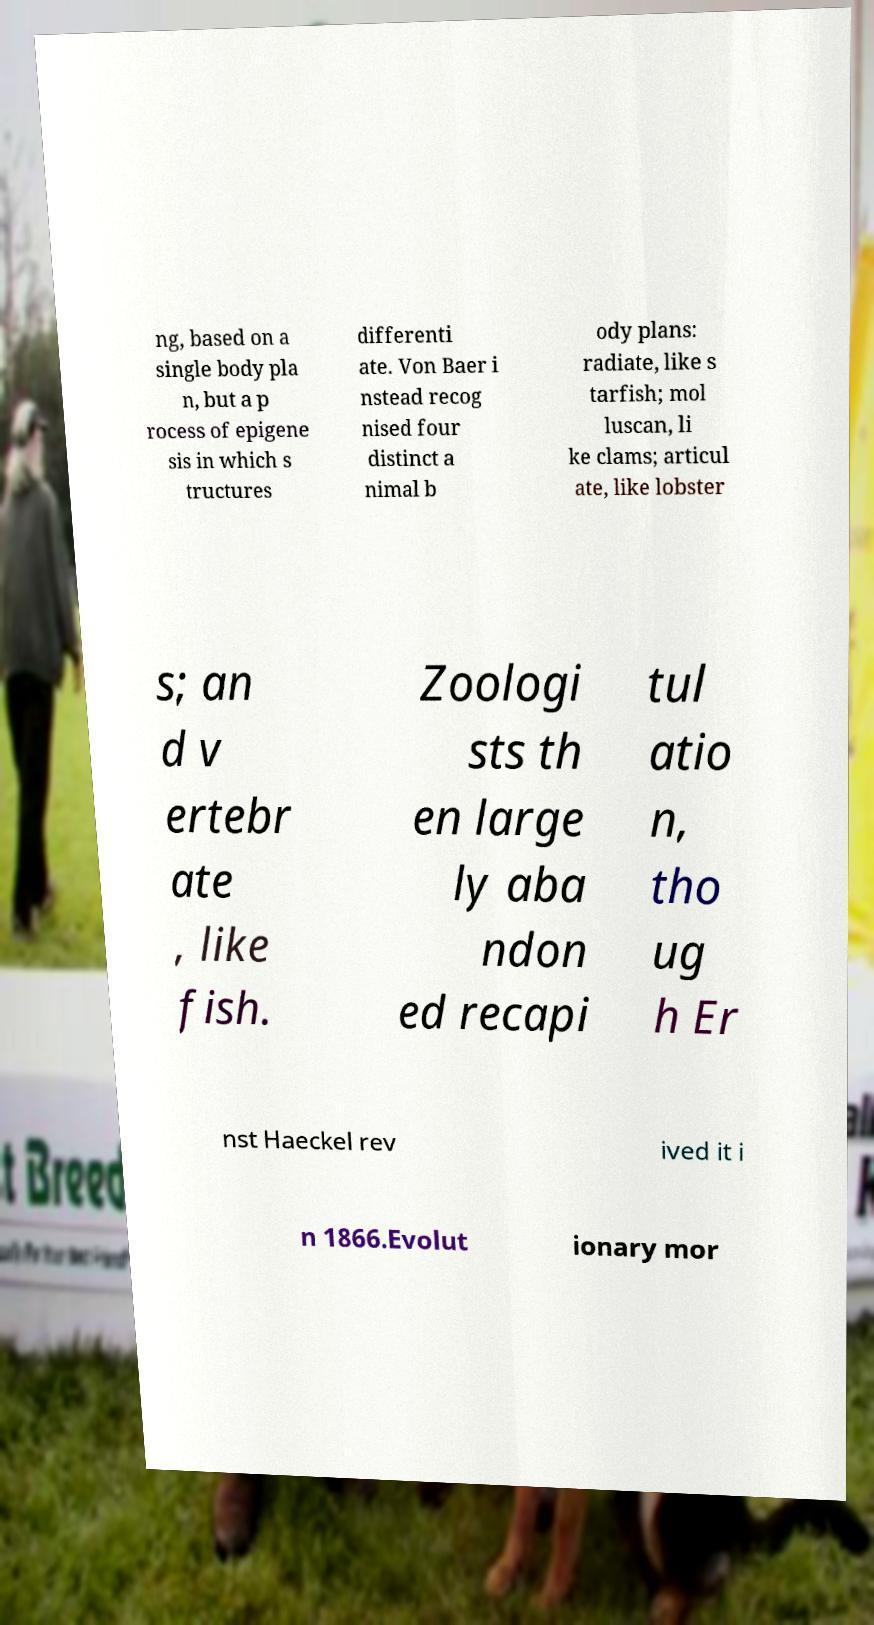Can you read and provide the text displayed in the image?This photo seems to have some interesting text. Can you extract and type it out for me? ng, based on a single body pla n, but a p rocess of epigene sis in which s tructures differenti ate. Von Baer i nstead recog nised four distinct a nimal b ody plans: radiate, like s tarfish; mol luscan, li ke clams; articul ate, like lobster s; an d v ertebr ate , like fish. Zoologi sts th en large ly aba ndon ed recapi tul atio n, tho ug h Er nst Haeckel rev ived it i n 1866.Evolut ionary mor 